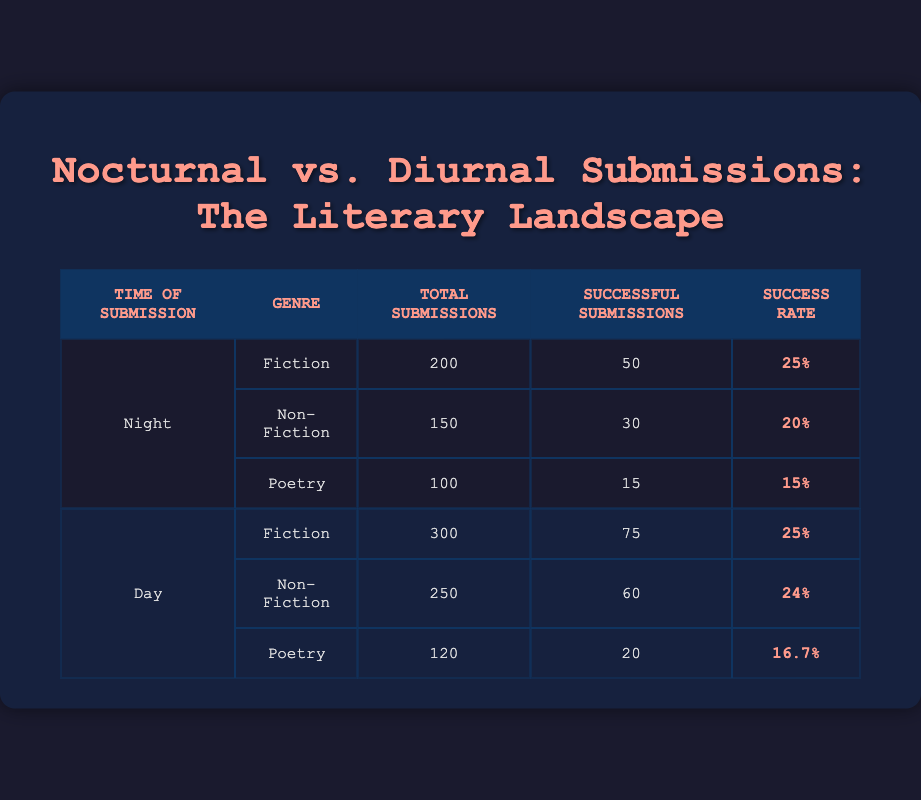What is the success rate for Fiction submissions made at night? From the table, the number of successful submissions for Fiction at night is 50 out of 200 total submissions. To calculate the success rate, divide successful submissions by total submissions and multiply by 100: (50/200) * 100 = 25%.
Answer: 25% What genre had the highest success rate during the day? Referring to the table, we see the success rates: Fiction 25%, Non-Fiction 24%, and Poetry 16.7%. Fiction has the highest rate at 25%.
Answer: Fiction How many total successful submissions were received at night? The table lists the successful submissions for genres at night as follows: Fiction 50, Non-Fiction 30, and Poetry 15. Adding these together: 50 + 30 + 15 = 95.
Answer: 95 Is the success rate for Non-Fiction submissions at night lower than at daytime? The success rate for Non-Fiction at night is 20% (30 successful out of 150 total), and for daytime is 24% (60 successful out of 250 total). Since 20% is less than 24%, the answer is yes.
Answer: Yes What is the total number of submissions for all genres during the day? Summing the total submissions for all genres during the day: Fiction 300, Non-Fiction 250, and Poetry 120 gives 300 + 250 + 120 = 670.
Answer: 670 In terms of successful submissions, how does Poetry at night compare to Poetry during the day? The successful submissions for Poetry at night are 15, while during the day it is 20. Therefore, Poetry submissions during the day are more successful than at night.
Answer: Day is more successful What is the average success rate of all submissions made at night? For night submissions: Fiction 25%, Non-Fiction 20%, and Poetry 15%. Average success rate = (25 + 20 + 15) / 3 = 60 / 3 = 20%.
Answer: 20% Was the number of Fiction submissions greater during the day than during the night? The table shows 300 Fiction submissions during the day and 200 submissions at night. Since 300 is greater than 200, the answer is yes.
Answer: Yes What percentage of total submissions are successful for Poetry at night? For Poetry at night, there are 15 successful submissions out of 100 total. To find the percentage: (15/100) * 100 = 15%.
Answer: 15% 